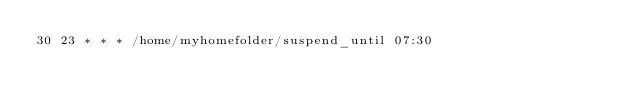Convert code to text. <code><loc_0><loc_0><loc_500><loc_500><_Bash_>30 23 * * * /home/myhomefolder/suspend_until 07:30
</code> 